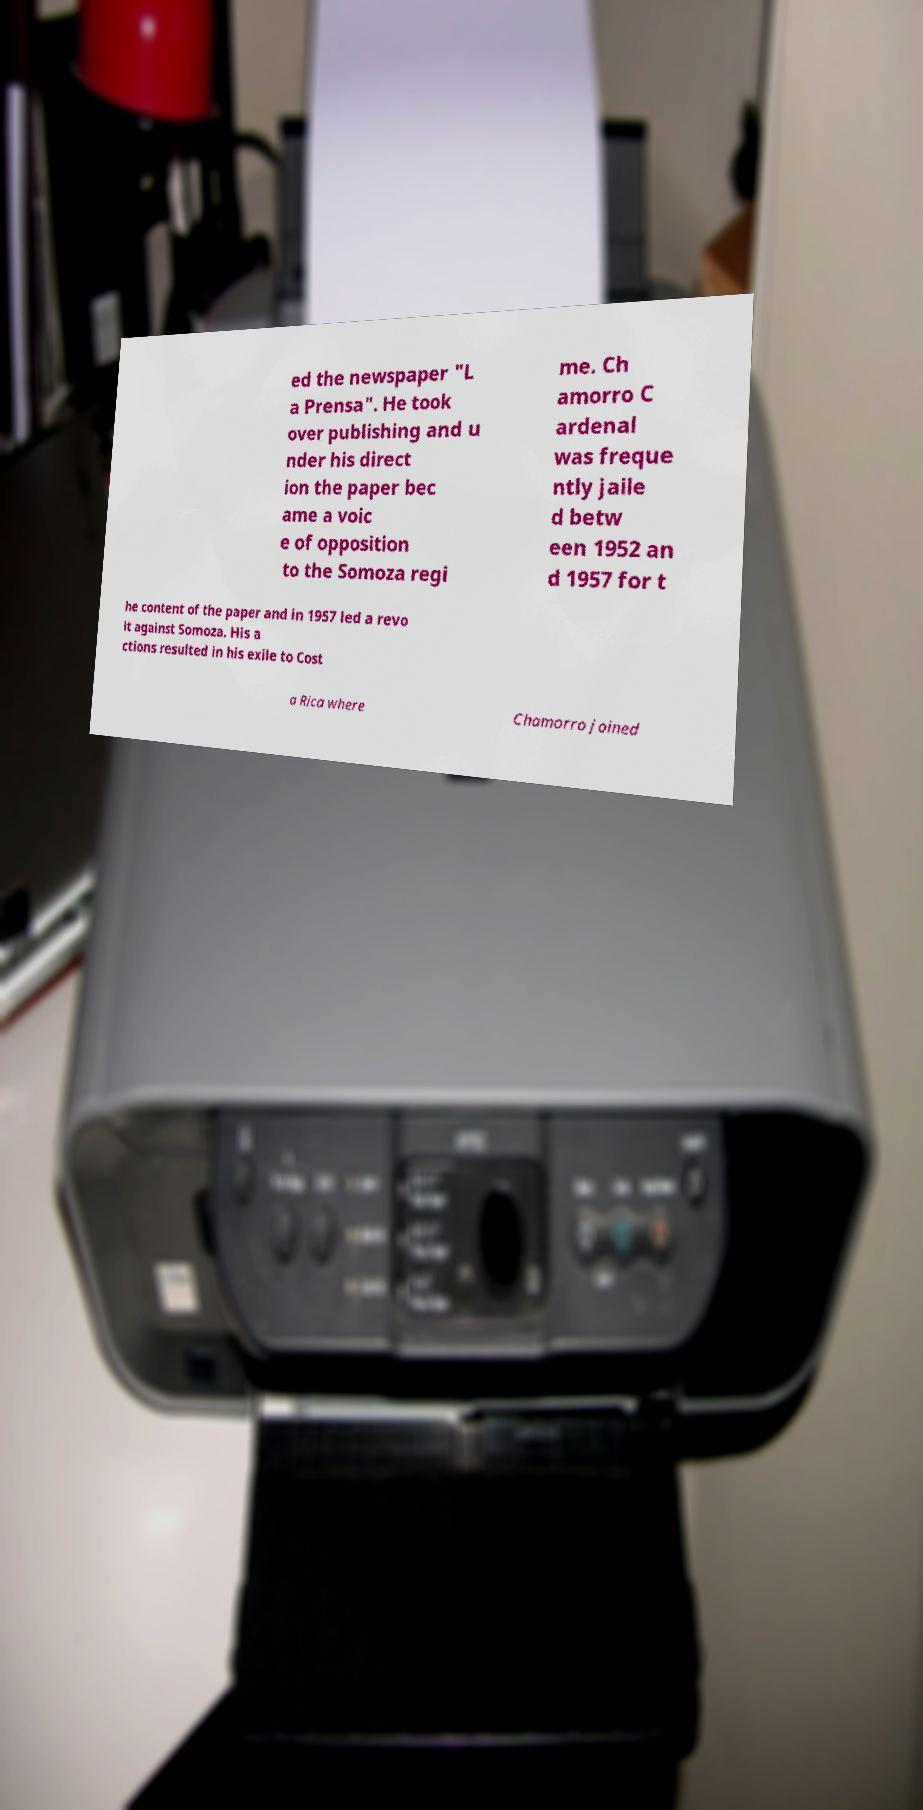I need the written content from this picture converted into text. Can you do that? ed the newspaper "L a Prensa". He took over publishing and u nder his direct ion the paper bec ame a voic e of opposition to the Somoza regi me. Ch amorro C ardenal was freque ntly jaile d betw een 1952 an d 1957 for t he content of the paper and in 1957 led a revo lt against Somoza. His a ctions resulted in his exile to Cost a Rica where Chamorro joined 